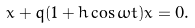Convert formula to latex. <formula><loc_0><loc_0><loc_500><loc_500>\ddot { x } + q ( 1 + h \cos \omega t ) x = 0 .</formula> 